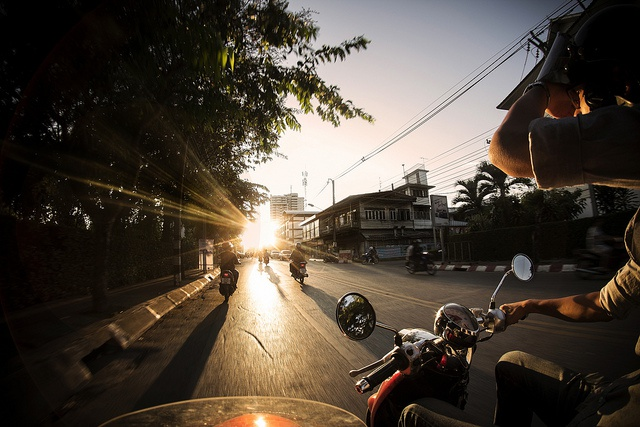Describe the objects in this image and their specific colors. I can see people in black, maroon, and brown tones, motorcycle in black, gray, and maroon tones, people in black, maroon, and brown tones, motorcycle in black, olive, and maroon tones, and motorcycle in black and gray tones in this image. 